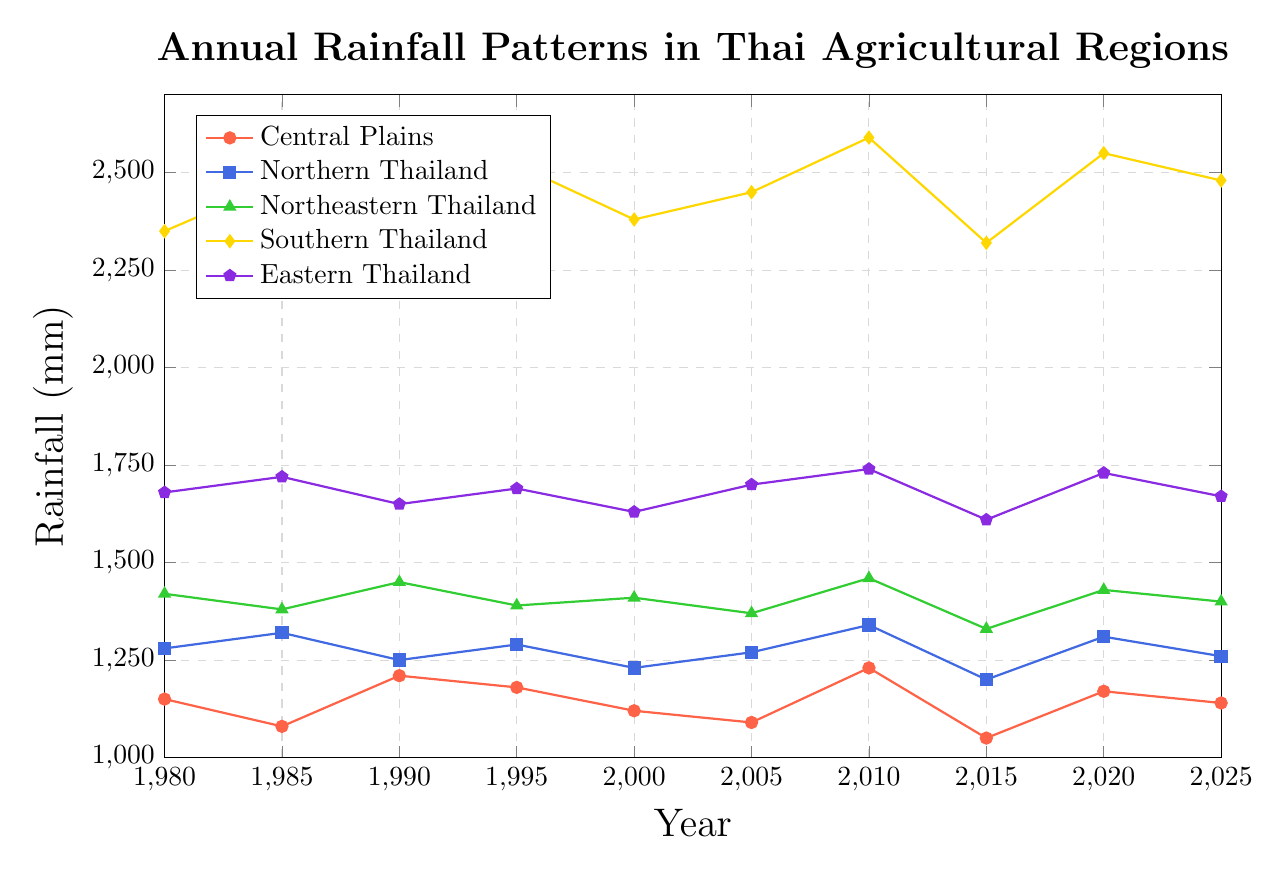Which region had the highest annual rainfall in 2020? Look at the y-axis value at the year 2020 for each region, identify the one with the highest value. Southern Thailand had 2550 mm, which is the highest.
Answer: Southern Thailand Which region shows an increasing trend in rainfall from 1980 to 2025? Identify regions where the rainfall values generally increase from 1980 to 2025. The Southern Thailand region shows an increasing trend overall.
Answer: Southern Thailand What was the rainfall difference between Northern Thailand and Northeastern Thailand in 2025? Find the values for Northern Thailand (1260 mm) and Northeastern Thailand (1400 mm) in 2025, then calculate the difference. 1400 - 1260 = 140.
Answer: 140 mm Which year did all regions experience a decrease in rainfall compared to the previous recorded year? Check for each region where the next year's rainfall is lower than the previous year's for all regions simultaneously. This happens between 2010 and 2015.
Answer: 2015 Between 1980 and 2025, in which year did Central Plains experience its lowest rainfall? In the Central Plains data, identify the year with the minimum value. The minimum value, 1050 mm, occurs in 2015.
Answer: 2015 On average, how much did the rainfall in Northeastern Thailand vary between 1980 and 2025? Calculate the standard deviation of the Northeastern Thailand rainfall values from 1980 to 2025. The standard deviation is roughly 40 mm.
Answer: 40 mm In what year did Eastern Thailand experience its peak rainfall? In the Eastern Thailand data, identify the year with the maximum value. The maximum value, 1740 mm, occurs in 2010.
Answer: 2010 Compare the rainfall in the Central Plains and Southern Thailand in 2005. Which region had more rainfall and by how much? Look at the 2005 rainfall values: Central Plains (1090 mm) and Southern Thailand (2450 mm), then compute the difference. 2450 - 1090 = 1360.
Answer: Southern Thailand by 1360 mm What is the overall trend for rainfall in Northern Thailand from 1980 to 2025? Examine the trajectory of the Northern Thailand line, noting that it fluctuates but shows no significant long-term increase or decrease.
Answer: Fluctuating, no significant trend How does the average rainfall of Central Plains compare to that of Eastern Thailand from 1980 to 2025? Calculate the average for each: Central Plains (min: 1050, max: 1230), Eastern Thailand (min: 1610, max: 1740). Compare the averages. Central Plains is generally lower.
Answer: Central Plains is generally lower 